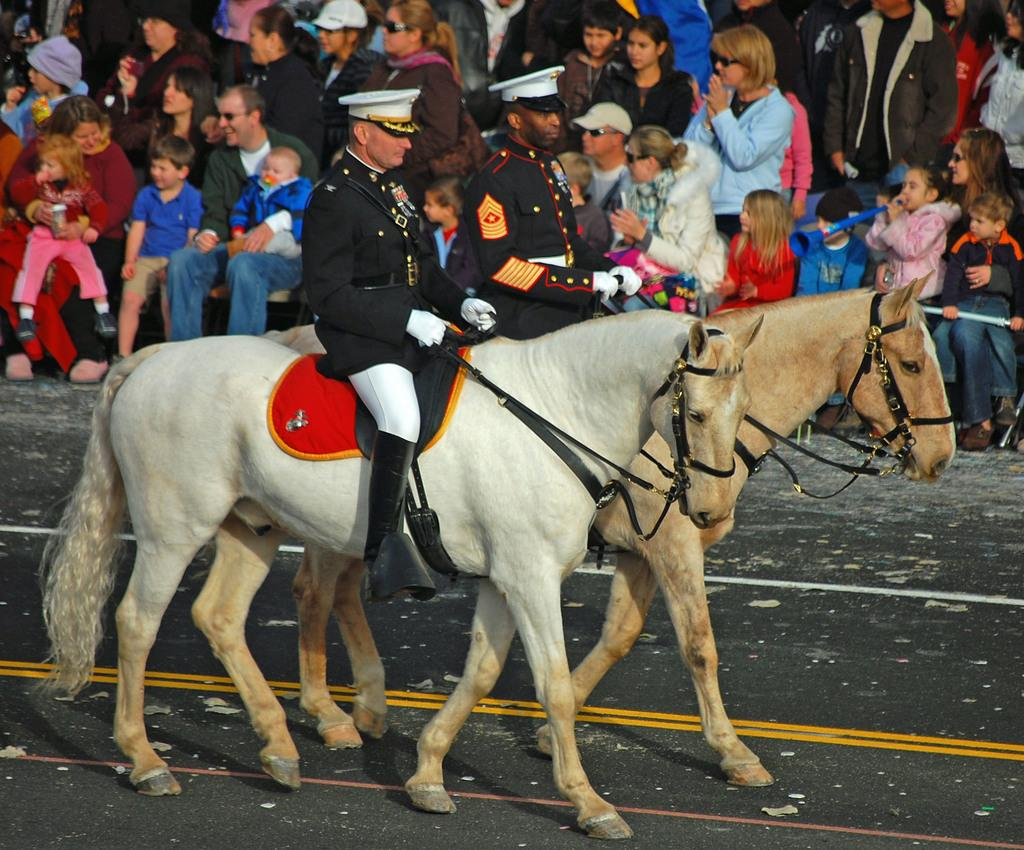How many people are in the image? There are two people in the image. What are the people wearing on their heads? Both people are wearing white caps. What are the people doing in the image? The people are riding on two different horses. Can you describe the background of the image? There is an audience visible in the background of the image. What type of disease is affecting the throat of the person on the left horse in the image? There is no indication of any disease or throat issue in the image; both people are wearing white caps and riding horses. 